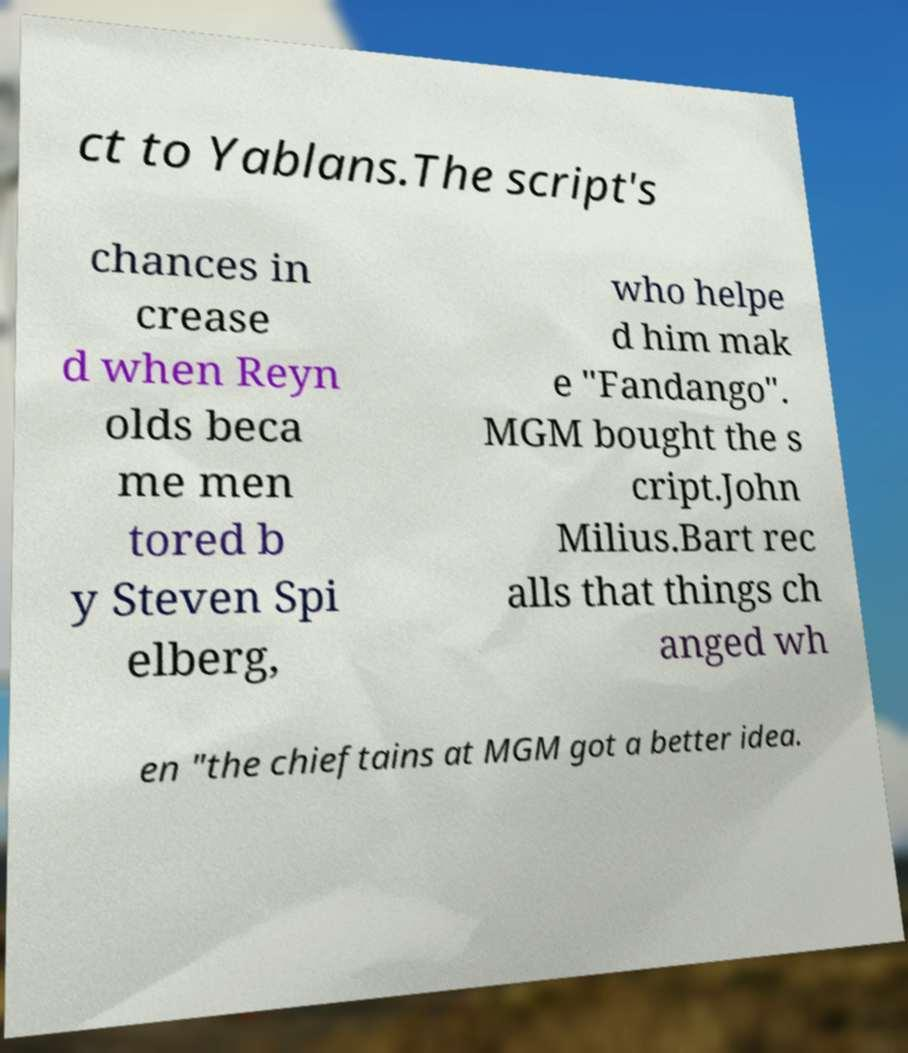Please read and relay the text visible in this image. What does it say? ct to Yablans.The script's chances in crease d when Reyn olds beca me men tored b y Steven Spi elberg, who helpe d him mak e "Fandango". MGM bought the s cript.John Milius.Bart rec alls that things ch anged wh en "the chieftains at MGM got a better idea. 